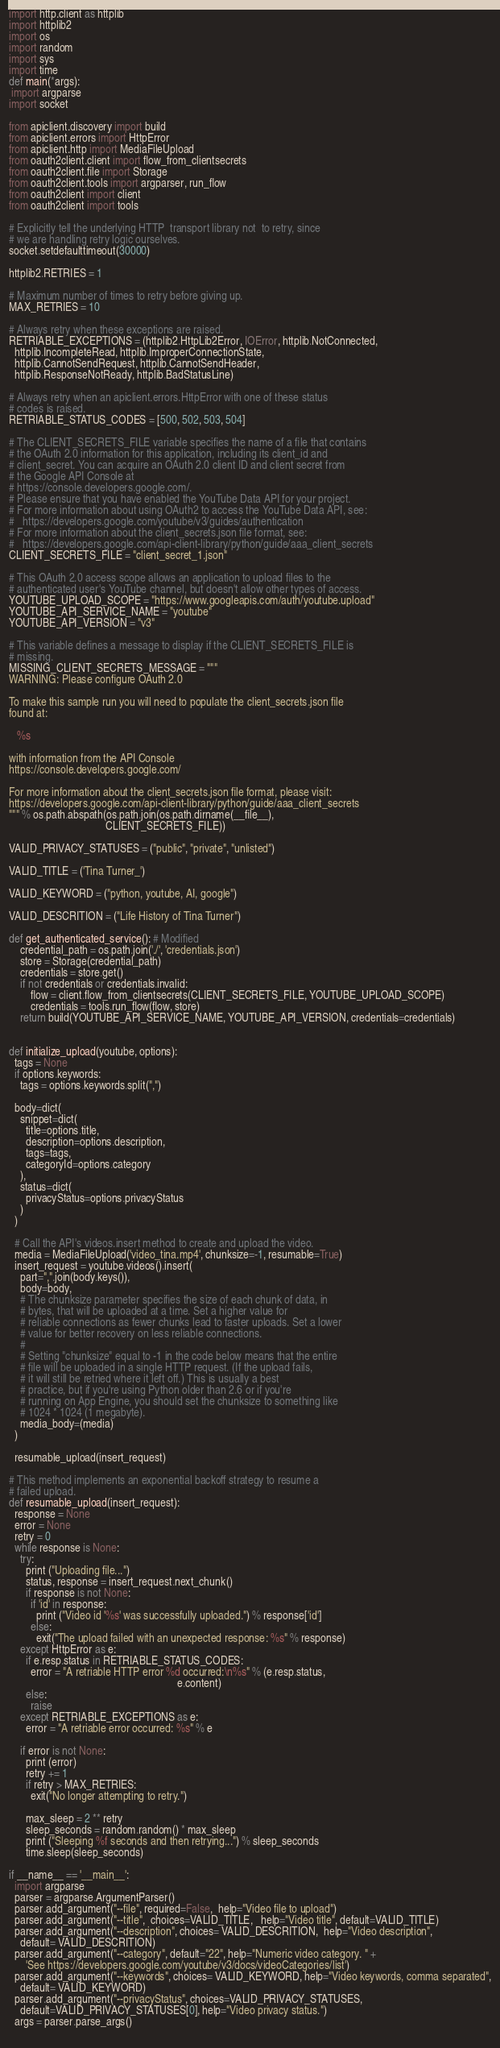<code> <loc_0><loc_0><loc_500><loc_500><_Python_>

import http.client as httplib
import httplib2
import os
import random
import sys
import time
def main(*args):
 import argparse
import socket

from apiclient.discovery import build
from apiclient.errors import HttpError
from apiclient.http import MediaFileUpload
from oauth2client.client import flow_from_clientsecrets
from oauth2client.file import Storage
from oauth2client.tools import argparser, run_flow
from oauth2client import client
from oauth2client import tools

# Explicitly tell the underlying HTTP  transport library not  to retry, since
# we are handling retry logic ourselves.
socket.setdefaulttimeout(30000)

httplib2.RETRIES = 1

# Maximum number of times to retry before giving up.
MAX_RETRIES = 10

# Always retry when these exceptions are raised.
RETRIABLE_EXCEPTIONS = (httplib2.HttpLib2Error, IOError, httplib.NotConnected,
  httplib.IncompleteRead, httplib.ImproperConnectionState,
  httplib.CannotSendRequest, httplib.CannotSendHeader,
  httplib.ResponseNotReady, httplib.BadStatusLine)

# Always retry when an apiclient.errors.HttpError with one of these status
# codes is raised.
RETRIABLE_STATUS_CODES = [500, 502, 503, 504]

# The CLIENT_SECRETS_FILE variable specifies the name of a file that contains
# the OAuth 2.0 information for this application, including its client_id and
# client_secret. You can acquire an OAuth 2.0 client ID and client secret from
# the Google API Console at
# https://console.developers.google.com/.
# Please ensure that you have enabled the YouTube Data API for your project.
# For more information about using OAuth2 to access the YouTube Data API, see:
#   https://developers.google.com/youtube/v3/guides/authentication
# For more information about the client_secrets.json file format, see:
#   https://developers.google.com/api-client-library/python/guide/aaa_client_secrets
CLIENT_SECRETS_FILE = "client_secret_1.json"

# This OAuth 2.0 access scope allows an application to upload files to the
# authenticated user's YouTube channel, but doesn't allow other types of access.
YOUTUBE_UPLOAD_SCOPE = "https://www.googleapis.com/auth/youtube.upload"
YOUTUBE_API_SERVICE_NAME = "youtube"
YOUTUBE_API_VERSION = "v3"

# This variable defines a message to display if the CLIENT_SECRETS_FILE is
# missing.
MISSING_CLIENT_SECRETS_MESSAGE = """
WARNING: Please configure OAuth 2.0

To make this sample run you will need to populate the client_secrets.json file
found at:

   %s

with information from the API Console
https://console.developers.google.com/

For more information about the client_secrets.json file format, please visit:
https://developers.google.com/api-client-library/python/guide/aaa_client_secrets
""" % os.path.abspath(os.path.join(os.path.dirname(__file__),
                                   CLIENT_SECRETS_FILE))

VALID_PRIVACY_STATUSES = ("public", "private", "unlisted")

VALID_TITLE = ('Tina Turner_')

VALID_KEYWORD = ("python, youtube, AI, google")

VALID_DESCRITION = ("Life History of Tina Turner")

def get_authenticated_service(): # Modified
    credential_path = os.path.join('./', 'credentials.json')
    store = Storage(credential_path)
    credentials = store.get()
    if not credentials or credentials.invalid:
        flow = client.flow_from_clientsecrets(CLIENT_SECRETS_FILE, YOUTUBE_UPLOAD_SCOPE)
        credentials = tools.run_flow(flow, store)
    return build(YOUTUBE_API_SERVICE_NAME, YOUTUBE_API_VERSION, credentials=credentials)


def initialize_upload(youtube, options):
  tags = None
  if options.keywords:
    tags = options.keywords.split(",")

  body=dict(
    snippet=dict(
      title=options.title,
      description=options.description,
      tags=tags,
      categoryId=options.category
    ),
    status=dict(
      privacyStatus=options.privacyStatus
    )
  )

  # Call the API's videos.insert method to create and upload the video.
  media = MediaFileUpload('video_tina.mp4', chunksize=-1, resumable=True)
  insert_request = youtube.videos().insert(
    part=",".join(body.keys()),
    body=body,
    # The chunksize parameter specifies the size of each chunk of data, in
    # bytes, that will be uploaded at a time. Set a higher value for
    # reliable connections as fewer chunks lead to faster uploads. Set a lower
    # value for better recovery on less reliable connections.
    #
    # Setting "chunksize" equal to -1 in the code below means that the entire
    # file will be uploaded in a single HTTP request. (If the upload fails,
    # it will still be retried where it left off.) This is usually a best
    # practice, but if you're using Python older than 2.6 or if you're
    # running on App Engine, you should set the chunksize to something like
    # 1024 * 1024 (1 megabyte).
    media_body=(media)
  )

  resumable_upload(insert_request)

# This method implements an exponential backoff strategy to resume a
# failed upload.
def resumable_upload(insert_request):
  response = None
  error = None
  retry = 0
  while response is None:
    try:
      print ("Uploading file...")
      status, response = insert_request.next_chunk()
      if response is not None:
        if 'id' in response:
          print ("Video id '%s' was successfully uploaded.") % response['id']
        else:
          exit("The upload failed with an unexpected response: %s" % response)
    except HttpError as e:
      if e.resp.status in RETRIABLE_STATUS_CODES:
        error = "A retriable HTTP error %d occurred:\n%s" % (e.resp.status,
                                                             e.content)
      else:
        raise
    except RETRIABLE_EXCEPTIONS as e:
      error = "A retriable error occurred: %s" % e

    if error is not None:
      print (error)
      retry += 1
      if retry > MAX_RETRIES:
        exit("No longer attempting to retry.")

      max_sleep = 2 ** retry
      sleep_seconds = random.random() * max_sleep
      print ("Sleeping %f seconds and then retrying...") % sleep_seconds
      time.sleep(sleep_seconds)

if __name__ == '__main__':
  import argparse
  parser = argparse.ArgumentParser()  
  parser.add_argument("--file", required=False,  help="Video file to upload")
  parser.add_argument("--title",  choices=VALID_TITLE,   help="Video title", default=VALID_TITLE)
  parser.add_argument("--description", choices= VALID_DESCRITION,  help="Video description",
    default= VALID_DESCRITION)
  parser.add_argument("--category", default="22", help="Numeric video category. " +
      'See https://developers.google.com/youtube/v3/docs/videoCategories/list') 
  parser.add_argument("--keywords", choices= VALID_KEYWORD, help="Video keywords, comma separated",
    default= VALID_KEYWORD)
  parser.add_argument("--privacyStatus", choices=VALID_PRIVACY_STATUSES,
    default=VALID_PRIVACY_STATUSES[0], help="Video privacy status.")
  args = parser.parse_args()
  
</code> 